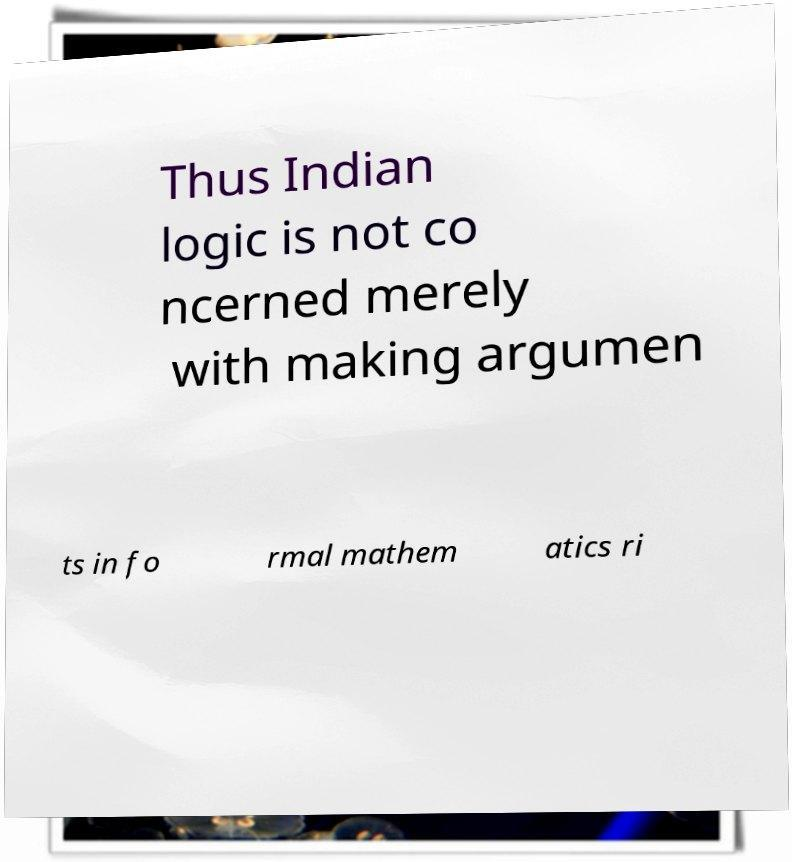I need the written content from this picture converted into text. Can you do that? Thus Indian logic is not co ncerned merely with making argumen ts in fo rmal mathem atics ri 